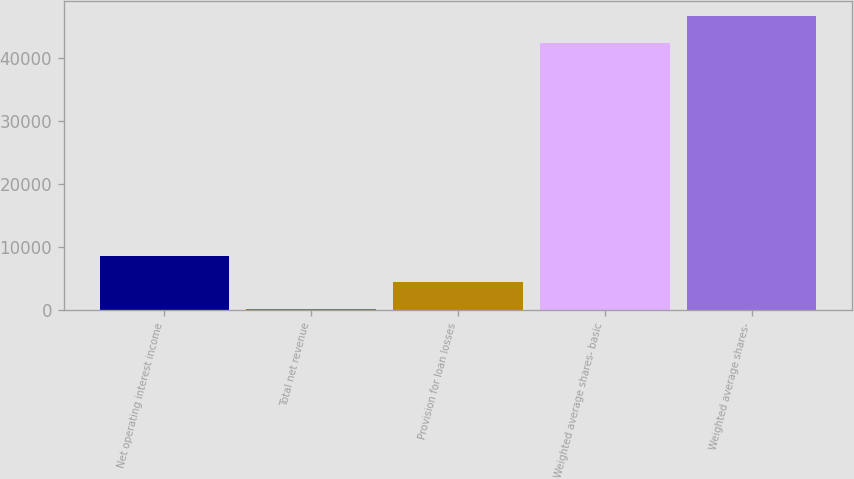Convert chart to OTSL. <chart><loc_0><loc_0><loc_500><loc_500><bar_chart><fcel>Net operating interest income<fcel>Total net revenue<fcel>Provision for loan losses<fcel>Weighted average shares- basic<fcel>Weighted average shares-<nl><fcel>8618.16<fcel>161.7<fcel>4389.93<fcel>42444<fcel>46672.2<nl></chart> 